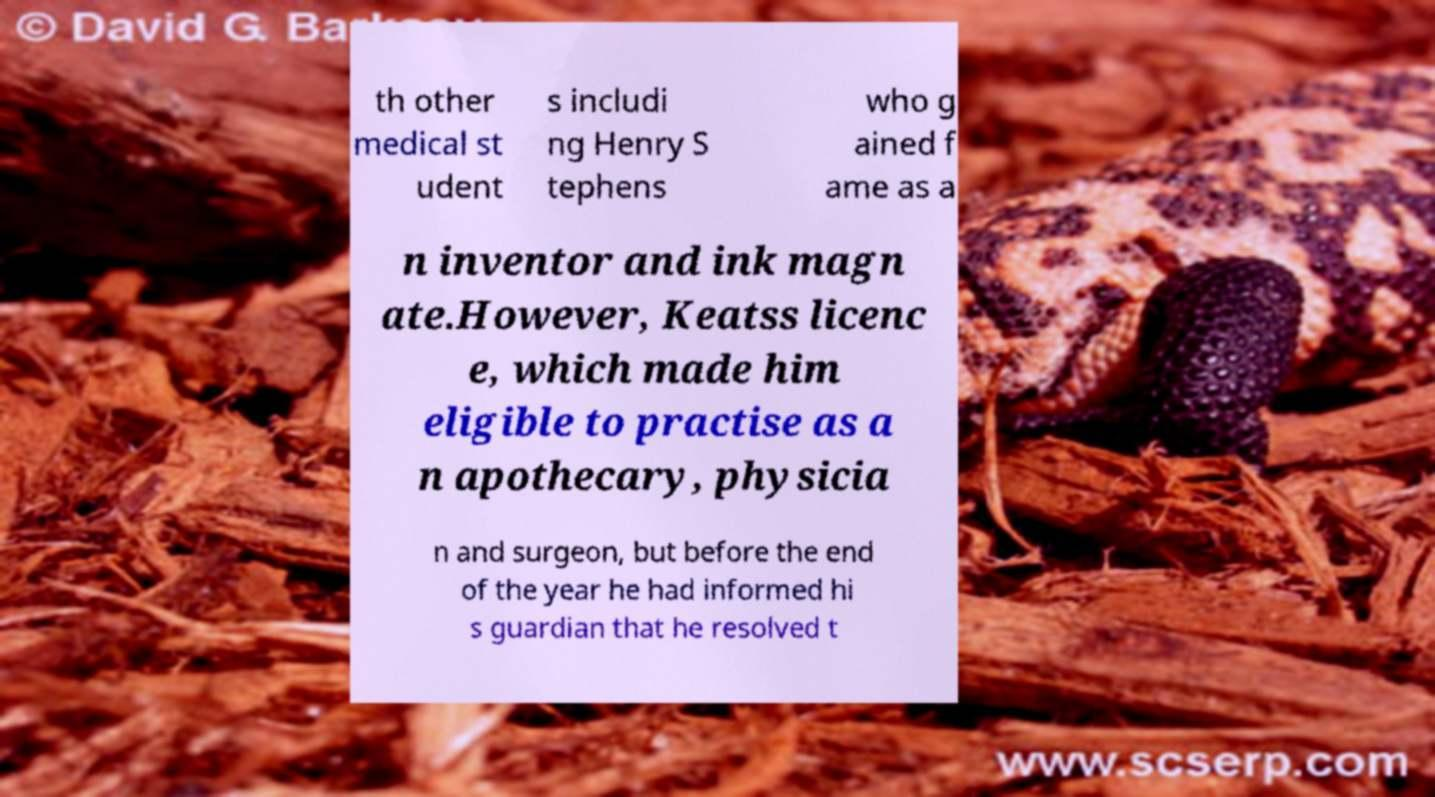Can you accurately transcribe the text from the provided image for me? th other medical st udent s includi ng Henry S tephens who g ained f ame as a n inventor and ink magn ate.However, Keatss licenc e, which made him eligible to practise as a n apothecary, physicia n and surgeon, but before the end of the year he had informed hi s guardian that he resolved t 